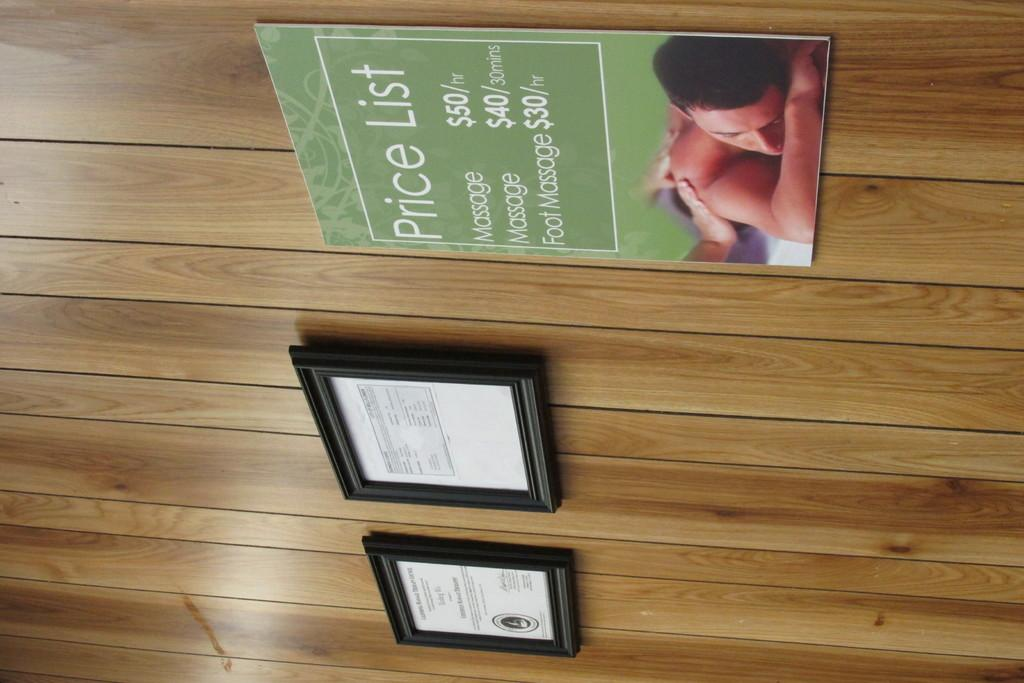What type of objects are displayed in the image? There are certificate frames in the image. What can be seen on the wooden wall in the image? There is a poster on the wooden wall in the image. Who or what is depicted on the poster? The poster features a person. What else is present on the poster besides the person? There is text on the poster. How many frogs are sitting on the collar in the image? There are no frogs or collars present in the image. 